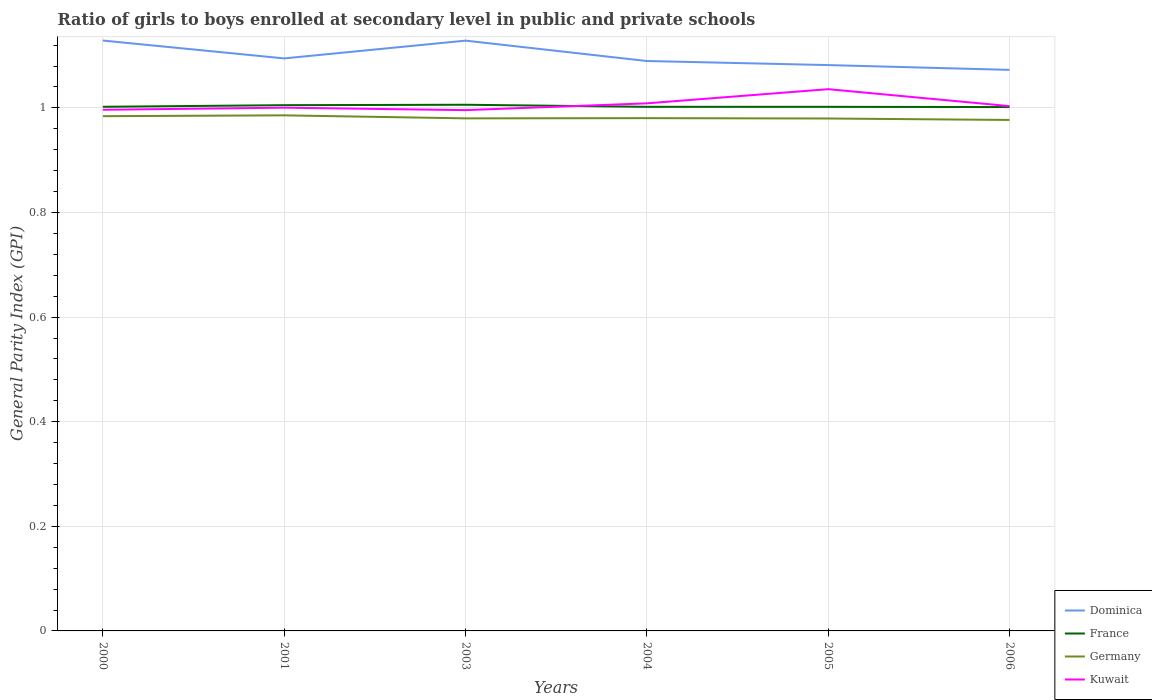Is the number of lines equal to the number of legend labels?
Keep it short and to the point. Yes. Across all years, what is the maximum general parity index in Dominica?
Make the answer very short. 1.07. In which year was the general parity index in Germany maximum?
Offer a very short reply. 2006. What is the total general parity index in Germany in the graph?
Offer a terse response. 0. What is the difference between the highest and the second highest general parity index in France?
Provide a short and direct response. 0. What is the difference between two consecutive major ticks on the Y-axis?
Provide a short and direct response. 0.2. Are the values on the major ticks of Y-axis written in scientific E-notation?
Your answer should be compact. No. Does the graph contain any zero values?
Ensure brevity in your answer.  No. Does the graph contain grids?
Give a very brief answer. Yes. What is the title of the graph?
Offer a terse response. Ratio of girls to boys enrolled at secondary level in public and private schools. Does "Mozambique" appear as one of the legend labels in the graph?
Your response must be concise. No. What is the label or title of the X-axis?
Keep it short and to the point. Years. What is the label or title of the Y-axis?
Make the answer very short. General Parity Index (GPI). What is the General Parity Index (GPI) in Dominica in 2000?
Offer a terse response. 1.13. What is the General Parity Index (GPI) in France in 2000?
Keep it short and to the point. 1. What is the General Parity Index (GPI) of Germany in 2000?
Your response must be concise. 0.98. What is the General Parity Index (GPI) in Kuwait in 2000?
Offer a very short reply. 1. What is the General Parity Index (GPI) in Dominica in 2001?
Provide a succinct answer. 1.09. What is the General Parity Index (GPI) of France in 2001?
Your response must be concise. 1.01. What is the General Parity Index (GPI) of Germany in 2001?
Provide a short and direct response. 0.99. What is the General Parity Index (GPI) of Kuwait in 2001?
Ensure brevity in your answer.  1. What is the General Parity Index (GPI) in Dominica in 2003?
Your answer should be very brief. 1.13. What is the General Parity Index (GPI) of France in 2003?
Keep it short and to the point. 1.01. What is the General Parity Index (GPI) of Germany in 2003?
Your answer should be very brief. 0.98. What is the General Parity Index (GPI) in Kuwait in 2003?
Offer a very short reply. 1. What is the General Parity Index (GPI) of Dominica in 2004?
Offer a very short reply. 1.09. What is the General Parity Index (GPI) in France in 2004?
Keep it short and to the point. 1. What is the General Parity Index (GPI) of Germany in 2004?
Offer a very short reply. 0.98. What is the General Parity Index (GPI) in Kuwait in 2004?
Provide a succinct answer. 1.01. What is the General Parity Index (GPI) of Dominica in 2005?
Offer a very short reply. 1.08. What is the General Parity Index (GPI) in France in 2005?
Keep it short and to the point. 1. What is the General Parity Index (GPI) of Germany in 2005?
Your answer should be very brief. 0.98. What is the General Parity Index (GPI) of Kuwait in 2005?
Offer a very short reply. 1.04. What is the General Parity Index (GPI) of Dominica in 2006?
Provide a succinct answer. 1.07. What is the General Parity Index (GPI) in France in 2006?
Your response must be concise. 1. What is the General Parity Index (GPI) in Germany in 2006?
Your answer should be very brief. 0.98. What is the General Parity Index (GPI) of Kuwait in 2006?
Your response must be concise. 1. Across all years, what is the maximum General Parity Index (GPI) in Dominica?
Offer a terse response. 1.13. Across all years, what is the maximum General Parity Index (GPI) in France?
Ensure brevity in your answer.  1.01. Across all years, what is the maximum General Parity Index (GPI) in Germany?
Your answer should be very brief. 0.99. Across all years, what is the maximum General Parity Index (GPI) of Kuwait?
Your answer should be compact. 1.04. Across all years, what is the minimum General Parity Index (GPI) in Dominica?
Offer a very short reply. 1.07. Across all years, what is the minimum General Parity Index (GPI) of France?
Ensure brevity in your answer.  1. Across all years, what is the minimum General Parity Index (GPI) of Germany?
Offer a very short reply. 0.98. Across all years, what is the minimum General Parity Index (GPI) in Kuwait?
Ensure brevity in your answer.  1. What is the total General Parity Index (GPI) in Dominica in the graph?
Your response must be concise. 6.6. What is the total General Parity Index (GPI) of France in the graph?
Ensure brevity in your answer.  6.02. What is the total General Parity Index (GPI) of Germany in the graph?
Provide a succinct answer. 5.89. What is the total General Parity Index (GPI) in Kuwait in the graph?
Give a very brief answer. 6.04. What is the difference between the General Parity Index (GPI) in Dominica in 2000 and that in 2001?
Your response must be concise. 0.03. What is the difference between the General Parity Index (GPI) in France in 2000 and that in 2001?
Provide a succinct answer. -0. What is the difference between the General Parity Index (GPI) in Germany in 2000 and that in 2001?
Your response must be concise. -0. What is the difference between the General Parity Index (GPI) in Kuwait in 2000 and that in 2001?
Your response must be concise. -0. What is the difference between the General Parity Index (GPI) in France in 2000 and that in 2003?
Ensure brevity in your answer.  -0. What is the difference between the General Parity Index (GPI) in Germany in 2000 and that in 2003?
Make the answer very short. 0. What is the difference between the General Parity Index (GPI) in Kuwait in 2000 and that in 2003?
Provide a succinct answer. 0. What is the difference between the General Parity Index (GPI) in Dominica in 2000 and that in 2004?
Make the answer very short. 0.04. What is the difference between the General Parity Index (GPI) in France in 2000 and that in 2004?
Your response must be concise. 0. What is the difference between the General Parity Index (GPI) in Germany in 2000 and that in 2004?
Keep it short and to the point. 0. What is the difference between the General Parity Index (GPI) in Kuwait in 2000 and that in 2004?
Make the answer very short. -0.01. What is the difference between the General Parity Index (GPI) of Dominica in 2000 and that in 2005?
Give a very brief answer. 0.05. What is the difference between the General Parity Index (GPI) of Germany in 2000 and that in 2005?
Make the answer very short. 0. What is the difference between the General Parity Index (GPI) in Kuwait in 2000 and that in 2005?
Provide a succinct answer. -0.04. What is the difference between the General Parity Index (GPI) in Dominica in 2000 and that in 2006?
Your answer should be very brief. 0.06. What is the difference between the General Parity Index (GPI) of Germany in 2000 and that in 2006?
Your answer should be very brief. 0.01. What is the difference between the General Parity Index (GPI) of Kuwait in 2000 and that in 2006?
Provide a succinct answer. -0.01. What is the difference between the General Parity Index (GPI) in Dominica in 2001 and that in 2003?
Make the answer very short. -0.03. What is the difference between the General Parity Index (GPI) in France in 2001 and that in 2003?
Make the answer very short. -0. What is the difference between the General Parity Index (GPI) in Germany in 2001 and that in 2003?
Your answer should be very brief. 0.01. What is the difference between the General Parity Index (GPI) of Kuwait in 2001 and that in 2003?
Provide a succinct answer. 0. What is the difference between the General Parity Index (GPI) in Dominica in 2001 and that in 2004?
Your response must be concise. 0.01. What is the difference between the General Parity Index (GPI) in France in 2001 and that in 2004?
Offer a very short reply. 0. What is the difference between the General Parity Index (GPI) in Germany in 2001 and that in 2004?
Offer a very short reply. 0.01. What is the difference between the General Parity Index (GPI) of Kuwait in 2001 and that in 2004?
Offer a very short reply. -0.01. What is the difference between the General Parity Index (GPI) of Dominica in 2001 and that in 2005?
Offer a terse response. 0.01. What is the difference between the General Parity Index (GPI) in France in 2001 and that in 2005?
Your answer should be very brief. 0. What is the difference between the General Parity Index (GPI) in Germany in 2001 and that in 2005?
Ensure brevity in your answer.  0.01. What is the difference between the General Parity Index (GPI) of Kuwait in 2001 and that in 2005?
Ensure brevity in your answer.  -0.04. What is the difference between the General Parity Index (GPI) in Dominica in 2001 and that in 2006?
Make the answer very short. 0.02. What is the difference between the General Parity Index (GPI) of France in 2001 and that in 2006?
Keep it short and to the point. 0. What is the difference between the General Parity Index (GPI) in Germany in 2001 and that in 2006?
Provide a short and direct response. 0.01. What is the difference between the General Parity Index (GPI) in Kuwait in 2001 and that in 2006?
Make the answer very short. -0. What is the difference between the General Parity Index (GPI) of Dominica in 2003 and that in 2004?
Offer a terse response. 0.04. What is the difference between the General Parity Index (GPI) of France in 2003 and that in 2004?
Keep it short and to the point. 0. What is the difference between the General Parity Index (GPI) in Germany in 2003 and that in 2004?
Your answer should be very brief. -0. What is the difference between the General Parity Index (GPI) in Kuwait in 2003 and that in 2004?
Ensure brevity in your answer.  -0.01. What is the difference between the General Parity Index (GPI) in Dominica in 2003 and that in 2005?
Offer a terse response. 0.05. What is the difference between the General Parity Index (GPI) of France in 2003 and that in 2005?
Your answer should be very brief. 0. What is the difference between the General Parity Index (GPI) in Kuwait in 2003 and that in 2005?
Provide a succinct answer. -0.04. What is the difference between the General Parity Index (GPI) of Dominica in 2003 and that in 2006?
Provide a short and direct response. 0.06. What is the difference between the General Parity Index (GPI) in France in 2003 and that in 2006?
Make the answer very short. 0. What is the difference between the General Parity Index (GPI) of Germany in 2003 and that in 2006?
Give a very brief answer. 0. What is the difference between the General Parity Index (GPI) of Kuwait in 2003 and that in 2006?
Your response must be concise. -0.01. What is the difference between the General Parity Index (GPI) of Dominica in 2004 and that in 2005?
Provide a short and direct response. 0.01. What is the difference between the General Parity Index (GPI) of Germany in 2004 and that in 2005?
Give a very brief answer. 0. What is the difference between the General Parity Index (GPI) of Kuwait in 2004 and that in 2005?
Provide a short and direct response. -0.03. What is the difference between the General Parity Index (GPI) in Dominica in 2004 and that in 2006?
Provide a short and direct response. 0.02. What is the difference between the General Parity Index (GPI) of France in 2004 and that in 2006?
Make the answer very short. 0. What is the difference between the General Parity Index (GPI) of Germany in 2004 and that in 2006?
Make the answer very short. 0. What is the difference between the General Parity Index (GPI) of Kuwait in 2004 and that in 2006?
Your answer should be compact. 0.01. What is the difference between the General Parity Index (GPI) of Dominica in 2005 and that in 2006?
Provide a succinct answer. 0.01. What is the difference between the General Parity Index (GPI) of France in 2005 and that in 2006?
Your answer should be very brief. 0. What is the difference between the General Parity Index (GPI) in Germany in 2005 and that in 2006?
Your response must be concise. 0. What is the difference between the General Parity Index (GPI) of Kuwait in 2005 and that in 2006?
Offer a very short reply. 0.03. What is the difference between the General Parity Index (GPI) of Dominica in 2000 and the General Parity Index (GPI) of France in 2001?
Your answer should be very brief. 0.12. What is the difference between the General Parity Index (GPI) in Dominica in 2000 and the General Parity Index (GPI) in Germany in 2001?
Ensure brevity in your answer.  0.14. What is the difference between the General Parity Index (GPI) in Dominica in 2000 and the General Parity Index (GPI) in Kuwait in 2001?
Make the answer very short. 0.13. What is the difference between the General Parity Index (GPI) in France in 2000 and the General Parity Index (GPI) in Germany in 2001?
Your answer should be compact. 0.02. What is the difference between the General Parity Index (GPI) of France in 2000 and the General Parity Index (GPI) of Kuwait in 2001?
Give a very brief answer. 0. What is the difference between the General Parity Index (GPI) in Germany in 2000 and the General Parity Index (GPI) in Kuwait in 2001?
Make the answer very short. -0.02. What is the difference between the General Parity Index (GPI) of Dominica in 2000 and the General Parity Index (GPI) of France in 2003?
Provide a short and direct response. 0.12. What is the difference between the General Parity Index (GPI) of Dominica in 2000 and the General Parity Index (GPI) of Germany in 2003?
Keep it short and to the point. 0.15. What is the difference between the General Parity Index (GPI) in Dominica in 2000 and the General Parity Index (GPI) in Kuwait in 2003?
Give a very brief answer. 0.13. What is the difference between the General Parity Index (GPI) of France in 2000 and the General Parity Index (GPI) of Germany in 2003?
Provide a short and direct response. 0.02. What is the difference between the General Parity Index (GPI) in France in 2000 and the General Parity Index (GPI) in Kuwait in 2003?
Make the answer very short. 0.01. What is the difference between the General Parity Index (GPI) of Germany in 2000 and the General Parity Index (GPI) of Kuwait in 2003?
Make the answer very short. -0.01. What is the difference between the General Parity Index (GPI) of Dominica in 2000 and the General Parity Index (GPI) of France in 2004?
Your answer should be very brief. 0.13. What is the difference between the General Parity Index (GPI) of Dominica in 2000 and the General Parity Index (GPI) of Germany in 2004?
Your answer should be very brief. 0.15. What is the difference between the General Parity Index (GPI) of Dominica in 2000 and the General Parity Index (GPI) of Kuwait in 2004?
Provide a succinct answer. 0.12. What is the difference between the General Parity Index (GPI) of France in 2000 and the General Parity Index (GPI) of Germany in 2004?
Your answer should be compact. 0.02. What is the difference between the General Parity Index (GPI) of France in 2000 and the General Parity Index (GPI) of Kuwait in 2004?
Make the answer very short. -0.01. What is the difference between the General Parity Index (GPI) in Germany in 2000 and the General Parity Index (GPI) in Kuwait in 2004?
Provide a succinct answer. -0.02. What is the difference between the General Parity Index (GPI) in Dominica in 2000 and the General Parity Index (GPI) in France in 2005?
Provide a succinct answer. 0.13. What is the difference between the General Parity Index (GPI) in Dominica in 2000 and the General Parity Index (GPI) in Germany in 2005?
Your answer should be very brief. 0.15. What is the difference between the General Parity Index (GPI) of Dominica in 2000 and the General Parity Index (GPI) of Kuwait in 2005?
Provide a short and direct response. 0.09. What is the difference between the General Parity Index (GPI) in France in 2000 and the General Parity Index (GPI) in Germany in 2005?
Provide a succinct answer. 0.02. What is the difference between the General Parity Index (GPI) in France in 2000 and the General Parity Index (GPI) in Kuwait in 2005?
Provide a short and direct response. -0.03. What is the difference between the General Parity Index (GPI) in Germany in 2000 and the General Parity Index (GPI) in Kuwait in 2005?
Provide a short and direct response. -0.05. What is the difference between the General Parity Index (GPI) in Dominica in 2000 and the General Parity Index (GPI) in France in 2006?
Ensure brevity in your answer.  0.13. What is the difference between the General Parity Index (GPI) of Dominica in 2000 and the General Parity Index (GPI) of Germany in 2006?
Provide a succinct answer. 0.15. What is the difference between the General Parity Index (GPI) in Dominica in 2000 and the General Parity Index (GPI) in Kuwait in 2006?
Make the answer very short. 0.13. What is the difference between the General Parity Index (GPI) in France in 2000 and the General Parity Index (GPI) in Germany in 2006?
Your response must be concise. 0.03. What is the difference between the General Parity Index (GPI) of France in 2000 and the General Parity Index (GPI) of Kuwait in 2006?
Provide a succinct answer. -0. What is the difference between the General Parity Index (GPI) in Germany in 2000 and the General Parity Index (GPI) in Kuwait in 2006?
Provide a short and direct response. -0.02. What is the difference between the General Parity Index (GPI) of Dominica in 2001 and the General Parity Index (GPI) of France in 2003?
Give a very brief answer. 0.09. What is the difference between the General Parity Index (GPI) of Dominica in 2001 and the General Parity Index (GPI) of Germany in 2003?
Keep it short and to the point. 0.11. What is the difference between the General Parity Index (GPI) of Dominica in 2001 and the General Parity Index (GPI) of Kuwait in 2003?
Ensure brevity in your answer.  0.1. What is the difference between the General Parity Index (GPI) of France in 2001 and the General Parity Index (GPI) of Germany in 2003?
Your answer should be very brief. 0.03. What is the difference between the General Parity Index (GPI) in France in 2001 and the General Parity Index (GPI) in Kuwait in 2003?
Make the answer very short. 0.01. What is the difference between the General Parity Index (GPI) of Germany in 2001 and the General Parity Index (GPI) of Kuwait in 2003?
Provide a short and direct response. -0.01. What is the difference between the General Parity Index (GPI) of Dominica in 2001 and the General Parity Index (GPI) of France in 2004?
Your answer should be very brief. 0.09. What is the difference between the General Parity Index (GPI) in Dominica in 2001 and the General Parity Index (GPI) in Germany in 2004?
Your answer should be compact. 0.11. What is the difference between the General Parity Index (GPI) of Dominica in 2001 and the General Parity Index (GPI) of Kuwait in 2004?
Ensure brevity in your answer.  0.09. What is the difference between the General Parity Index (GPI) of France in 2001 and the General Parity Index (GPI) of Germany in 2004?
Provide a short and direct response. 0.02. What is the difference between the General Parity Index (GPI) in France in 2001 and the General Parity Index (GPI) in Kuwait in 2004?
Your response must be concise. -0. What is the difference between the General Parity Index (GPI) in Germany in 2001 and the General Parity Index (GPI) in Kuwait in 2004?
Make the answer very short. -0.02. What is the difference between the General Parity Index (GPI) of Dominica in 2001 and the General Parity Index (GPI) of France in 2005?
Your answer should be very brief. 0.09. What is the difference between the General Parity Index (GPI) of Dominica in 2001 and the General Parity Index (GPI) of Germany in 2005?
Give a very brief answer. 0.11. What is the difference between the General Parity Index (GPI) in Dominica in 2001 and the General Parity Index (GPI) in Kuwait in 2005?
Provide a short and direct response. 0.06. What is the difference between the General Parity Index (GPI) of France in 2001 and the General Parity Index (GPI) of Germany in 2005?
Offer a very short reply. 0.03. What is the difference between the General Parity Index (GPI) of France in 2001 and the General Parity Index (GPI) of Kuwait in 2005?
Keep it short and to the point. -0.03. What is the difference between the General Parity Index (GPI) in Germany in 2001 and the General Parity Index (GPI) in Kuwait in 2005?
Ensure brevity in your answer.  -0.05. What is the difference between the General Parity Index (GPI) in Dominica in 2001 and the General Parity Index (GPI) in France in 2006?
Your response must be concise. 0.09. What is the difference between the General Parity Index (GPI) in Dominica in 2001 and the General Parity Index (GPI) in Germany in 2006?
Give a very brief answer. 0.12. What is the difference between the General Parity Index (GPI) of Dominica in 2001 and the General Parity Index (GPI) of Kuwait in 2006?
Provide a short and direct response. 0.09. What is the difference between the General Parity Index (GPI) in France in 2001 and the General Parity Index (GPI) in Germany in 2006?
Ensure brevity in your answer.  0.03. What is the difference between the General Parity Index (GPI) in France in 2001 and the General Parity Index (GPI) in Kuwait in 2006?
Provide a short and direct response. 0. What is the difference between the General Parity Index (GPI) of Germany in 2001 and the General Parity Index (GPI) of Kuwait in 2006?
Your answer should be very brief. -0.02. What is the difference between the General Parity Index (GPI) of Dominica in 2003 and the General Parity Index (GPI) of France in 2004?
Your response must be concise. 0.13. What is the difference between the General Parity Index (GPI) of Dominica in 2003 and the General Parity Index (GPI) of Germany in 2004?
Your response must be concise. 0.15. What is the difference between the General Parity Index (GPI) of Dominica in 2003 and the General Parity Index (GPI) of Kuwait in 2004?
Offer a terse response. 0.12. What is the difference between the General Parity Index (GPI) of France in 2003 and the General Parity Index (GPI) of Germany in 2004?
Your response must be concise. 0.03. What is the difference between the General Parity Index (GPI) in France in 2003 and the General Parity Index (GPI) in Kuwait in 2004?
Your answer should be very brief. -0. What is the difference between the General Parity Index (GPI) of Germany in 2003 and the General Parity Index (GPI) of Kuwait in 2004?
Give a very brief answer. -0.03. What is the difference between the General Parity Index (GPI) in Dominica in 2003 and the General Parity Index (GPI) in France in 2005?
Provide a succinct answer. 0.13. What is the difference between the General Parity Index (GPI) in Dominica in 2003 and the General Parity Index (GPI) in Germany in 2005?
Your answer should be compact. 0.15. What is the difference between the General Parity Index (GPI) in Dominica in 2003 and the General Parity Index (GPI) in Kuwait in 2005?
Offer a terse response. 0.09. What is the difference between the General Parity Index (GPI) of France in 2003 and the General Parity Index (GPI) of Germany in 2005?
Provide a succinct answer. 0.03. What is the difference between the General Parity Index (GPI) in France in 2003 and the General Parity Index (GPI) in Kuwait in 2005?
Offer a very short reply. -0.03. What is the difference between the General Parity Index (GPI) of Germany in 2003 and the General Parity Index (GPI) of Kuwait in 2005?
Your answer should be very brief. -0.06. What is the difference between the General Parity Index (GPI) in Dominica in 2003 and the General Parity Index (GPI) in France in 2006?
Your answer should be compact. 0.13. What is the difference between the General Parity Index (GPI) in Dominica in 2003 and the General Parity Index (GPI) in Germany in 2006?
Offer a very short reply. 0.15. What is the difference between the General Parity Index (GPI) of Dominica in 2003 and the General Parity Index (GPI) of Kuwait in 2006?
Your response must be concise. 0.13. What is the difference between the General Parity Index (GPI) of France in 2003 and the General Parity Index (GPI) of Germany in 2006?
Give a very brief answer. 0.03. What is the difference between the General Parity Index (GPI) in France in 2003 and the General Parity Index (GPI) in Kuwait in 2006?
Your answer should be compact. 0. What is the difference between the General Parity Index (GPI) of Germany in 2003 and the General Parity Index (GPI) of Kuwait in 2006?
Give a very brief answer. -0.02. What is the difference between the General Parity Index (GPI) in Dominica in 2004 and the General Parity Index (GPI) in France in 2005?
Make the answer very short. 0.09. What is the difference between the General Parity Index (GPI) in Dominica in 2004 and the General Parity Index (GPI) in Germany in 2005?
Provide a succinct answer. 0.11. What is the difference between the General Parity Index (GPI) of Dominica in 2004 and the General Parity Index (GPI) of Kuwait in 2005?
Give a very brief answer. 0.05. What is the difference between the General Parity Index (GPI) in France in 2004 and the General Parity Index (GPI) in Germany in 2005?
Your response must be concise. 0.02. What is the difference between the General Parity Index (GPI) in France in 2004 and the General Parity Index (GPI) in Kuwait in 2005?
Your answer should be compact. -0.03. What is the difference between the General Parity Index (GPI) of Germany in 2004 and the General Parity Index (GPI) of Kuwait in 2005?
Your answer should be very brief. -0.06. What is the difference between the General Parity Index (GPI) in Dominica in 2004 and the General Parity Index (GPI) in France in 2006?
Make the answer very short. 0.09. What is the difference between the General Parity Index (GPI) of Dominica in 2004 and the General Parity Index (GPI) of Germany in 2006?
Offer a very short reply. 0.11. What is the difference between the General Parity Index (GPI) of Dominica in 2004 and the General Parity Index (GPI) of Kuwait in 2006?
Your answer should be very brief. 0.09. What is the difference between the General Parity Index (GPI) in France in 2004 and the General Parity Index (GPI) in Germany in 2006?
Ensure brevity in your answer.  0.03. What is the difference between the General Parity Index (GPI) of France in 2004 and the General Parity Index (GPI) of Kuwait in 2006?
Your answer should be compact. -0. What is the difference between the General Parity Index (GPI) in Germany in 2004 and the General Parity Index (GPI) in Kuwait in 2006?
Provide a short and direct response. -0.02. What is the difference between the General Parity Index (GPI) in Dominica in 2005 and the General Parity Index (GPI) in France in 2006?
Offer a very short reply. 0.08. What is the difference between the General Parity Index (GPI) in Dominica in 2005 and the General Parity Index (GPI) in Germany in 2006?
Provide a succinct answer. 0.1. What is the difference between the General Parity Index (GPI) of Dominica in 2005 and the General Parity Index (GPI) of Kuwait in 2006?
Provide a short and direct response. 0.08. What is the difference between the General Parity Index (GPI) in France in 2005 and the General Parity Index (GPI) in Germany in 2006?
Provide a succinct answer. 0.03. What is the difference between the General Parity Index (GPI) in France in 2005 and the General Parity Index (GPI) in Kuwait in 2006?
Make the answer very short. -0. What is the difference between the General Parity Index (GPI) of Germany in 2005 and the General Parity Index (GPI) of Kuwait in 2006?
Your response must be concise. -0.02. What is the average General Parity Index (GPI) in Dominica per year?
Give a very brief answer. 1.1. What is the average General Parity Index (GPI) of Germany per year?
Provide a succinct answer. 0.98. In the year 2000, what is the difference between the General Parity Index (GPI) in Dominica and General Parity Index (GPI) in France?
Offer a very short reply. 0.13. In the year 2000, what is the difference between the General Parity Index (GPI) in Dominica and General Parity Index (GPI) in Germany?
Provide a succinct answer. 0.14. In the year 2000, what is the difference between the General Parity Index (GPI) of Dominica and General Parity Index (GPI) of Kuwait?
Provide a short and direct response. 0.13. In the year 2000, what is the difference between the General Parity Index (GPI) in France and General Parity Index (GPI) in Germany?
Your answer should be very brief. 0.02. In the year 2000, what is the difference between the General Parity Index (GPI) in France and General Parity Index (GPI) in Kuwait?
Provide a short and direct response. 0.01. In the year 2000, what is the difference between the General Parity Index (GPI) in Germany and General Parity Index (GPI) in Kuwait?
Give a very brief answer. -0.01. In the year 2001, what is the difference between the General Parity Index (GPI) of Dominica and General Parity Index (GPI) of France?
Your answer should be compact. 0.09. In the year 2001, what is the difference between the General Parity Index (GPI) in Dominica and General Parity Index (GPI) in Germany?
Your answer should be very brief. 0.11. In the year 2001, what is the difference between the General Parity Index (GPI) of Dominica and General Parity Index (GPI) of Kuwait?
Keep it short and to the point. 0.09. In the year 2001, what is the difference between the General Parity Index (GPI) in France and General Parity Index (GPI) in Germany?
Your answer should be compact. 0.02. In the year 2001, what is the difference between the General Parity Index (GPI) in France and General Parity Index (GPI) in Kuwait?
Your answer should be compact. 0. In the year 2001, what is the difference between the General Parity Index (GPI) in Germany and General Parity Index (GPI) in Kuwait?
Offer a very short reply. -0.01. In the year 2003, what is the difference between the General Parity Index (GPI) in Dominica and General Parity Index (GPI) in France?
Offer a terse response. 0.12. In the year 2003, what is the difference between the General Parity Index (GPI) in Dominica and General Parity Index (GPI) in Germany?
Provide a succinct answer. 0.15. In the year 2003, what is the difference between the General Parity Index (GPI) of Dominica and General Parity Index (GPI) of Kuwait?
Make the answer very short. 0.13. In the year 2003, what is the difference between the General Parity Index (GPI) of France and General Parity Index (GPI) of Germany?
Provide a short and direct response. 0.03. In the year 2003, what is the difference between the General Parity Index (GPI) in France and General Parity Index (GPI) in Kuwait?
Keep it short and to the point. 0.01. In the year 2003, what is the difference between the General Parity Index (GPI) in Germany and General Parity Index (GPI) in Kuwait?
Offer a very short reply. -0.02. In the year 2004, what is the difference between the General Parity Index (GPI) in Dominica and General Parity Index (GPI) in France?
Offer a very short reply. 0.09. In the year 2004, what is the difference between the General Parity Index (GPI) of Dominica and General Parity Index (GPI) of Germany?
Your answer should be compact. 0.11. In the year 2004, what is the difference between the General Parity Index (GPI) in Dominica and General Parity Index (GPI) in Kuwait?
Provide a short and direct response. 0.08. In the year 2004, what is the difference between the General Parity Index (GPI) of France and General Parity Index (GPI) of Germany?
Your answer should be very brief. 0.02. In the year 2004, what is the difference between the General Parity Index (GPI) in France and General Parity Index (GPI) in Kuwait?
Make the answer very short. -0.01. In the year 2004, what is the difference between the General Parity Index (GPI) of Germany and General Parity Index (GPI) of Kuwait?
Provide a succinct answer. -0.03. In the year 2005, what is the difference between the General Parity Index (GPI) in Dominica and General Parity Index (GPI) in France?
Keep it short and to the point. 0.08. In the year 2005, what is the difference between the General Parity Index (GPI) in Dominica and General Parity Index (GPI) in Germany?
Provide a succinct answer. 0.1. In the year 2005, what is the difference between the General Parity Index (GPI) in Dominica and General Parity Index (GPI) in Kuwait?
Give a very brief answer. 0.05. In the year 2005, what is the difference between the General Parity Index (GPI) of France and General Parity Index (GPI) of Germany?
Your answer should be compact. 0.02. In the year 2005, what is the difference between the General Parity Index (GPI) in France and General Parity Index (GPI) in Kuwait?
Your answer should be very brief. -0.03. In the year 2005, what is the difference between the General Parity Index (GPI) of Germany and General Parity Index (GPI) of Kuwait?
Your answer should be compact. -0.06. In the year 2006, what is the difference between the General Parity Index (GPI) of Dominica and General Parity Index (GPI) of France?
Keep it short and to the point. 0.07. In the year 2006, what is the difference between the General Parity Index (GPI) in Dominica and General Parity Index (GPI) in Germany?
Make the answer very short. 0.1. In the year 2006, what is the difference between the General Parity Index (GPI) in Dominica and General Parity Index (GPI) in Kuwait?
Make the answer very short. 0.07. In the year 2006, what is the difference between the General Parity Index (GPI) in France and General Parity Index (GPI) in Germany?
Give a very brief answer. 0.02. In the year 2006, what is the difference between the General Parity Index (GPI) in France and General Parity Index (GPI) in Kuwait?
Give a very brief answer. -0. In the year 2006, what is the difference between the General Parity Index (GPI) of Germany and General Parity Index (GPI) of Kuwait?
Your response must be concise. -0.03. What is the ratio of the General Parity Index (GPI) in Dominica in 2000 to that in 2001?
Your answer should be compact. 1.03. What is the ratio of the General Parity Index (GPI) in France in 2000 to that in 2001?
Ensure brevity in your answer.  1. What is the ratio of the General Parity Index (GPI) of Kuwait in 2000 to that in 2001?
Your answer should be very brief. 1. What is the ratio of the General Parity Index (GPI) of Dominica in 2000 to that in 2003?
Your answer should be compact. 1. What is the ratio of the General Parity Index (GPI) in France in 2000 to that in 2003?
Provide a succinct answer. 1. What is the ratio of the General Parity Index (GPI) in Dominica in 2000 to that in 2004?
Provide a succinct answer. 1.04. What is the ratio of the General Parity Index (GPI) in France in 2000 to that in 2004?
Offer a very short reply. 1. What is the ratio of the General Parity Index (GPI) of Dominica in 2000 to that in 2005?
Your answer should be very brief. 1.04. What is the ratio of the General Parity Index (GPI) of Germany in 2000 to that in 2005?
Give a very brief answer. 1. What is the ratio of the General Parity Index (GPI) in Kuwait in 2000 to that in 2005?
Your response must be concise. 0.96. What is the ratio of the General Parity Index (GPI) of Dominica in 2000 to that in 2006?
Give a very brief answer. 1.05. What is the ratio of the General Parity Index (GPI) of France in 2000 to that in 2006?
Your response must be concise. 1. What is the ratio of the General Parity Index (GPI) of Germany in 2000 to that in 2006?
Ensure brevity in your answer.  1.01. What is the ratio of the General Parity Index (GPI) in Kuwait in 2000 to that in 2006?
Offer a terse response. 0.99. What is the ratio of the General Parity Index (GPI) of Dominica in 2001 to that in 2003?
Keep it short and to the point. 0.97. What is the ratio of the General Parity Index (GPI) of Germany in 2001 to that in 2003?
Your answer should be very brief. 1.01. What is the ratio of the General Parity Index (GPI) of Kuwait in 2001 to that in 2003?
Offer a terse response. 1. What is the ratio of the General Parity Index (GPI) of Germany in 2001 to that in 2004?
Your answer should be compact. 1.01. What is the ratio of the General Parity Index (GPI) in Kuwait in 2001 to that in 2004?
Give a very brief answer. 0.99. What is the ratio of the General Parity Index (GPI) in Dominica in 2001 to that in 2005?
Your answer should be very brief. 1.01. What is the ratio of the General Parity Index (GPI) of France in 2001 to that in 2005?
Your answer should be very brief. 1. What is the ratio of the General Parity Index (GPI) in Germany in 2001 to that in 2005?
Provide a short and direct response. 1.01. What is the ratio of the General Parity Index (GPI) in Kuwait in 2001 to that in 2005?
Provide a short and direct response. 0.97. What is the ratio of the General Parity Index (GPI) in Dominica in 2001 to that in 2006?
Provide a short and direct response. 1.02. What is the ratio of the General Parity Index (GPI) in Germany in 2001 to that in 2006?
Your answer should be compact. 1.01. What is the ratio of the General Parity Index (GPI) of Kuwait in 2001 to that in 2006?
Keep it short and to the point. 1. What is the ratio of the General Parity Index (GPI) in Dominica in 2003 to that in 2004?
Offer a terse response. 1.04. What is the ratio of the General Parity Index (GPI) in France in 2003 to that in 2004?
Your answer should be very brief. 1. What is the ratio of the General Parity Index (GPI) of Germany in 2003 to that in 2004?
Offer a terse response. 1. What is the ratio of the General Parity Index (GPI) of Kuwait in 2003 to that in 2004?
Keep it short and to the point. 0.99. What is the ratio of the General Parity Index (GPI) of Dominica in 2003 to that in 2005?
Provide a short and direct response. 1.04. What is the ratio of the General Parity Index (GPI) of Germany in 2003 to that in 2005?
Provide a short and direct response. 1. What is the ratio of the General Parity Index (GPI) of Kuwait in 2003 to that in 2005?
Make the answer very short. 0.96. What is the ratio of the General Parity Index (GPI) in Dominica in 2003 to that in 2006?
Make the answer very short. 1.05. What is the ratio of the General Parity Index (GPI) in Germany in 2003 to that in 2006?
Offer a terse response. 1. What is the ratio of the General Parity Index (GPI) in Kuwait in 2004 to that in 2005?
Give a very brief answer. 0.97. What is the ratio of the General Parity Index (GPI) of Dominica in 2004 to that in 2006?
Provide a short and direct response. 1.02. What is the ratio of the General Parity Index (GPI) in Germany in 2004 to that in 2006?
Your answer should be compact. 1. What is the ratio of the General Parity Index (GPI) in Kuwait in 2004 to that in 2006?
Provide a short and direct response. 1.01. What is the ratio of the General Parity Index (GPI) of Dominica in 2005 to that in 2006?
Ensure brevity in your answer.  1.01. What is the ratio of the General Parity Index (GPI) of France in 2005 to that in 2006?
Keep it short and to the point. 1. What is the ratio of the General Parity Index (GPI) of Kuwait in 2005 to that in 2006?
Keep it short and to the point. 1.03. What is the difference between the highest and the second highest General Parity Index (GPI) of France?
Offer a very short reply. 0. What is the difference between the highest and the second highest General Parity Index (GPI) of Germany?
Your answer should be compact. 0. What is the difference between the highest and the second highest General Parity Index (GPI) in Kuwait?
Ensure brevity in your answer.  0.03. What is the difference between the highest and the lowest General Parity Index (GPI) of Dominica?
Give a very brief answer. 0.06. What is the difference between the highest and the lowest General Parity Index (GPI) in France?
Give a very brief answer. 0. What is the difference between the highest and the lowest General Parity Index (GPI) in Germany?
Offer a terse response. 0.01. What is the difference between the highest and the lowest General Parity Index (GPI) in Kuwait?
Keep it short and to the point. 0.04. 